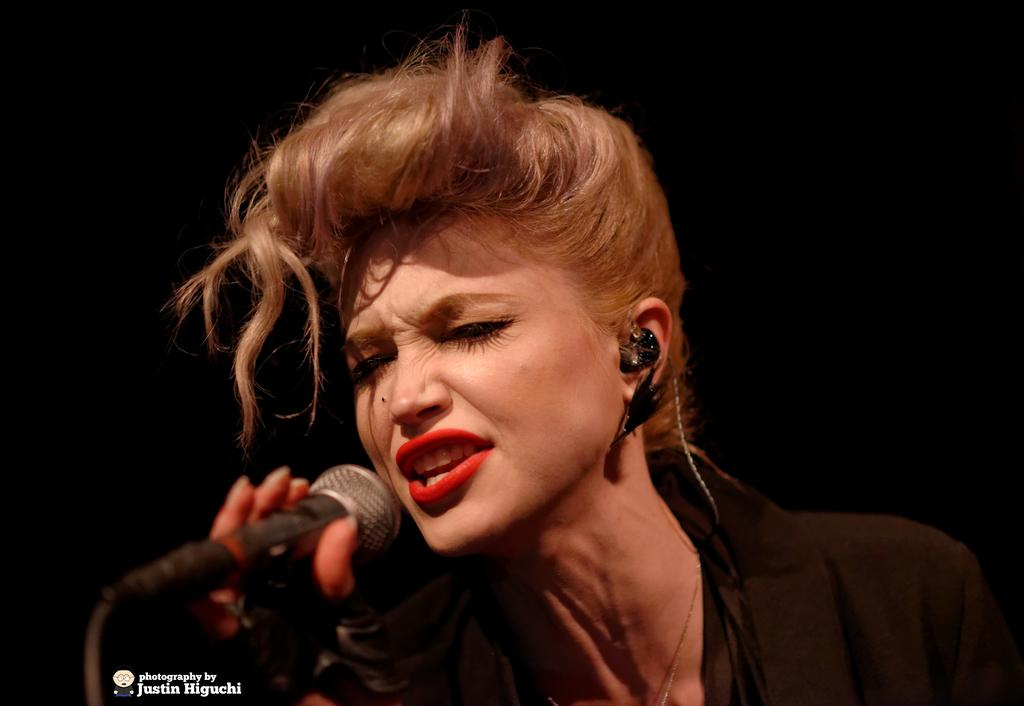Who is the main subject in the image? There is a woman in the image. What is the woman wearing? The woman is wearing a black dress. What is the woman holding in the image? The woman is holding a mic. Can you describe the background of the image? The background of the image is dark. What type of leather is visible on the woman's shoes in the image? There is no mention of shoes or leather in the image, so we cannot determine the type of leather visible. 